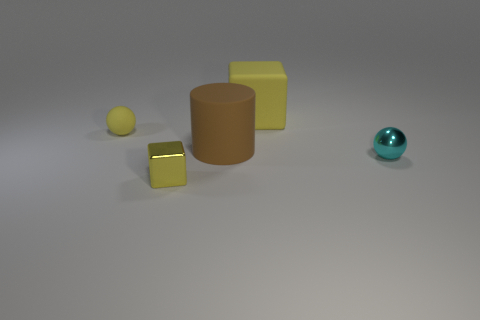Add 5 big cyan matte blocks. How many objects exist? 10 Subtract 1 spheres. How many spheres are left? 1 Subtract all cylinders. How many objects are left? 4 Add 1 yellow rubber things. How many yellow rubber things exist? 3 Subtract 0 cyan cylinders. How many objects are left? 5 Subtract all purple blocks. Subtract all blue spheres. How many blocks are left? 2 Subtract all large rubber objects. Subtract all small yellow matte balls. How many objects are left? 2 Add 5 yellow spheres. How many yellow spheres are left? 6 